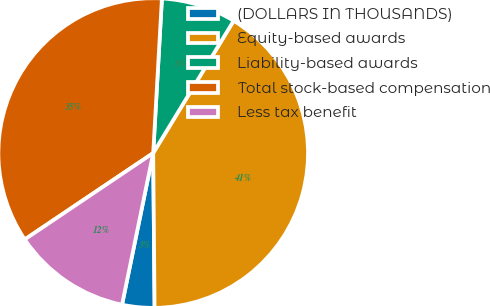Convert chart. <chart><loc_0><loc_0><loc_500><loc_500><pie_chart><fcel>(DOLLARS IN THOUSANDS)<fcel>Equity-based awards<fcel>Liability-based awards<fcel>Total stock-based compensation<fcel>Less tax benefit<nl><fcel>3.37%<fcel>41.16%<fcel>7.8%<fcel>35.32%<fcel>12.35%<nl></chart> 